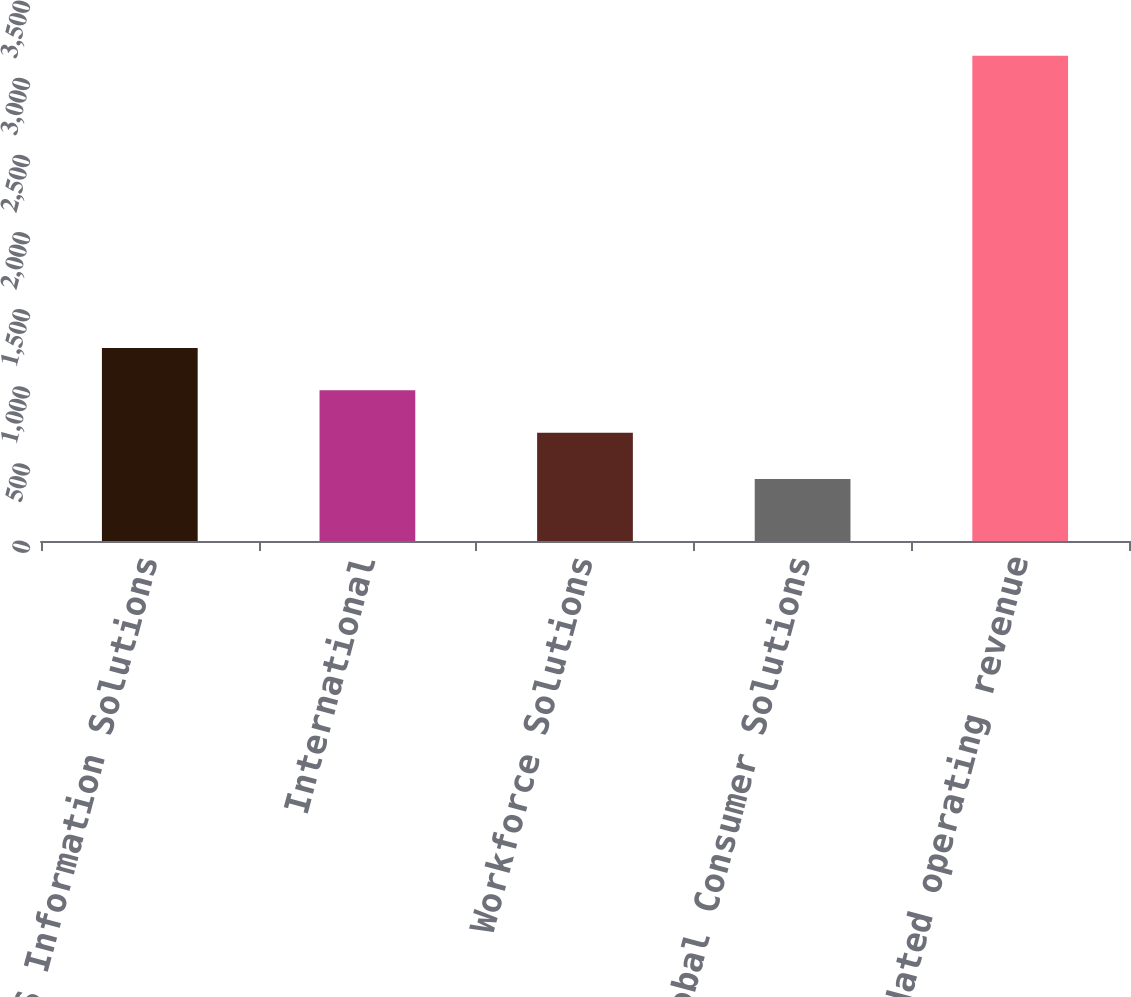Convert chart to OTSL. <chart><loc_0><loc_0><loc_500><loc_500><bar_chart><fcel>US Information Solutions<fcel>International<fcel>Workforce Solutions<fcel>Global Consumer Solutions<fcel>Consolidated operating revenue<nl><fcel>1250.66<fcel>976.43<fcel>702.2<fcel>402.6<fcel>3144.9<nl></chart> 